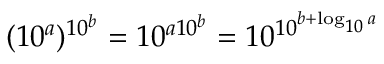<formula> <loc_0><loc_0><loc_500><loc_500>( 1 0 ^ { a } ) ^ { \, 1 0 ^ { b } } = 1 0 ^ { a 1 0 ^ { b } } = 1 0 ^ { 1 0 ^ { b + \log _ { 1 0 } a } }</formula> 